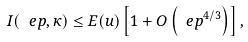<formula> <loc_0><loc_0><loc_500><loc_500>I ( \ e p , \kappa ) \leq E ( u ) \left [ 1 + O \left ( \ e p ^ { 4 / 3 } \right ) \right ] ,</formula> 